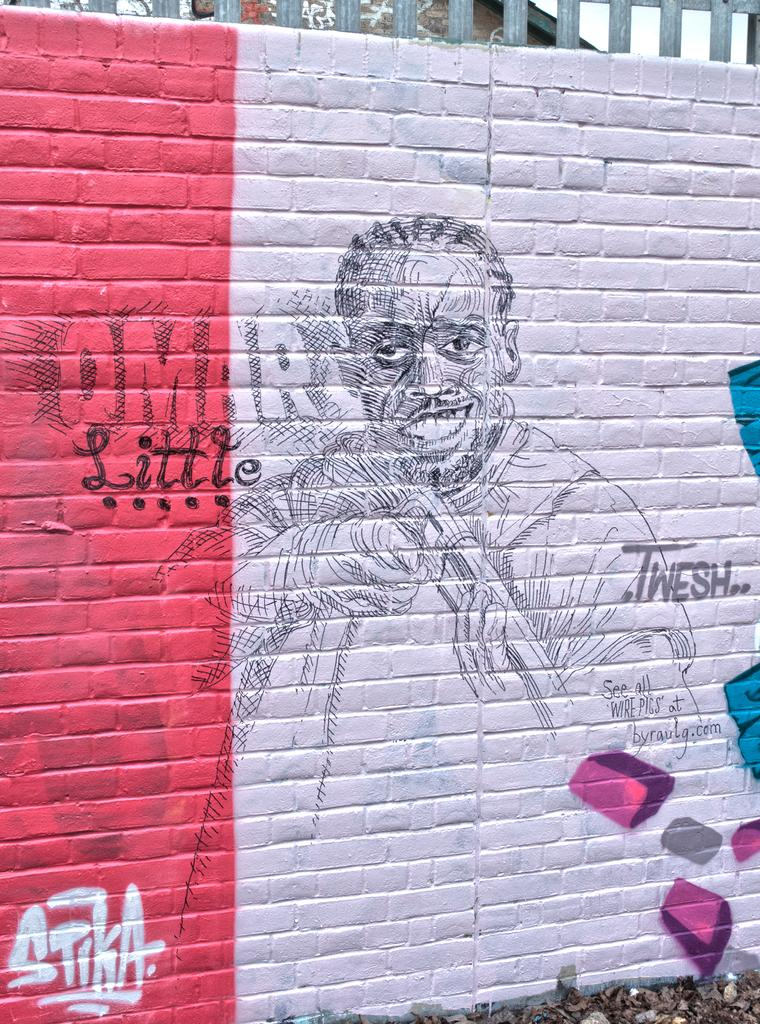What is the main feature of the image? There is a wall in the image. What is depicted on the wall? The wall is painted with a picture. Are there any words on the wall? Yes, there is text written on the wall. What is located behind the wall in the image? There is a fence at the back of the wall. Can you tell me how many buttons are on the doctor's coat in the image? There is no doctor or button present in the image. Is there a fight happening in the image? There is no fight depicted in the image; it features a wall with a picture and text. 